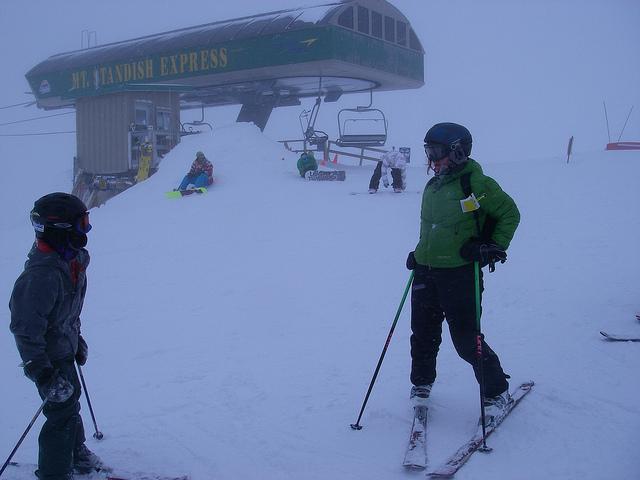Is this the express?
Concise answer only. Yes. What mountain are they on?
Answer briefly. Standish. What color is the lady's coat?
Short answer required. Green. 